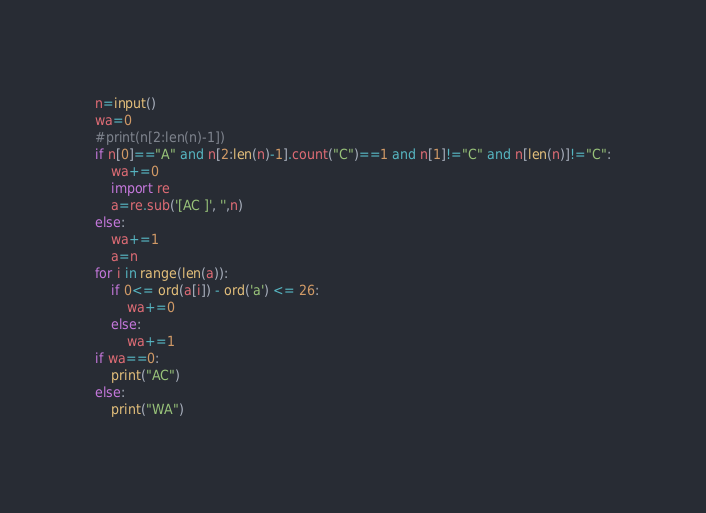<code> <loc_0><loc_0><loc_500><loc_500><_Python_>n=input()
wa=0
#print(n[2:len(n)-1])
if n[0]=="A" and n[2:len(n)-1].count("C")==1 and n[1]!="C" and n[len(n)]!="C":
    wa+=0
    import re
    a=re.sub('[AC ]', '',n)
else:
    wa+=1
    a=n
for i in range(len(a)):
    if 0<= ord(a[i]) - ord('a') <= 26:
        wa+=0
    else:
        wa+=1
if wa==0:
    print("AC")
else:
    print("WA")</code> 